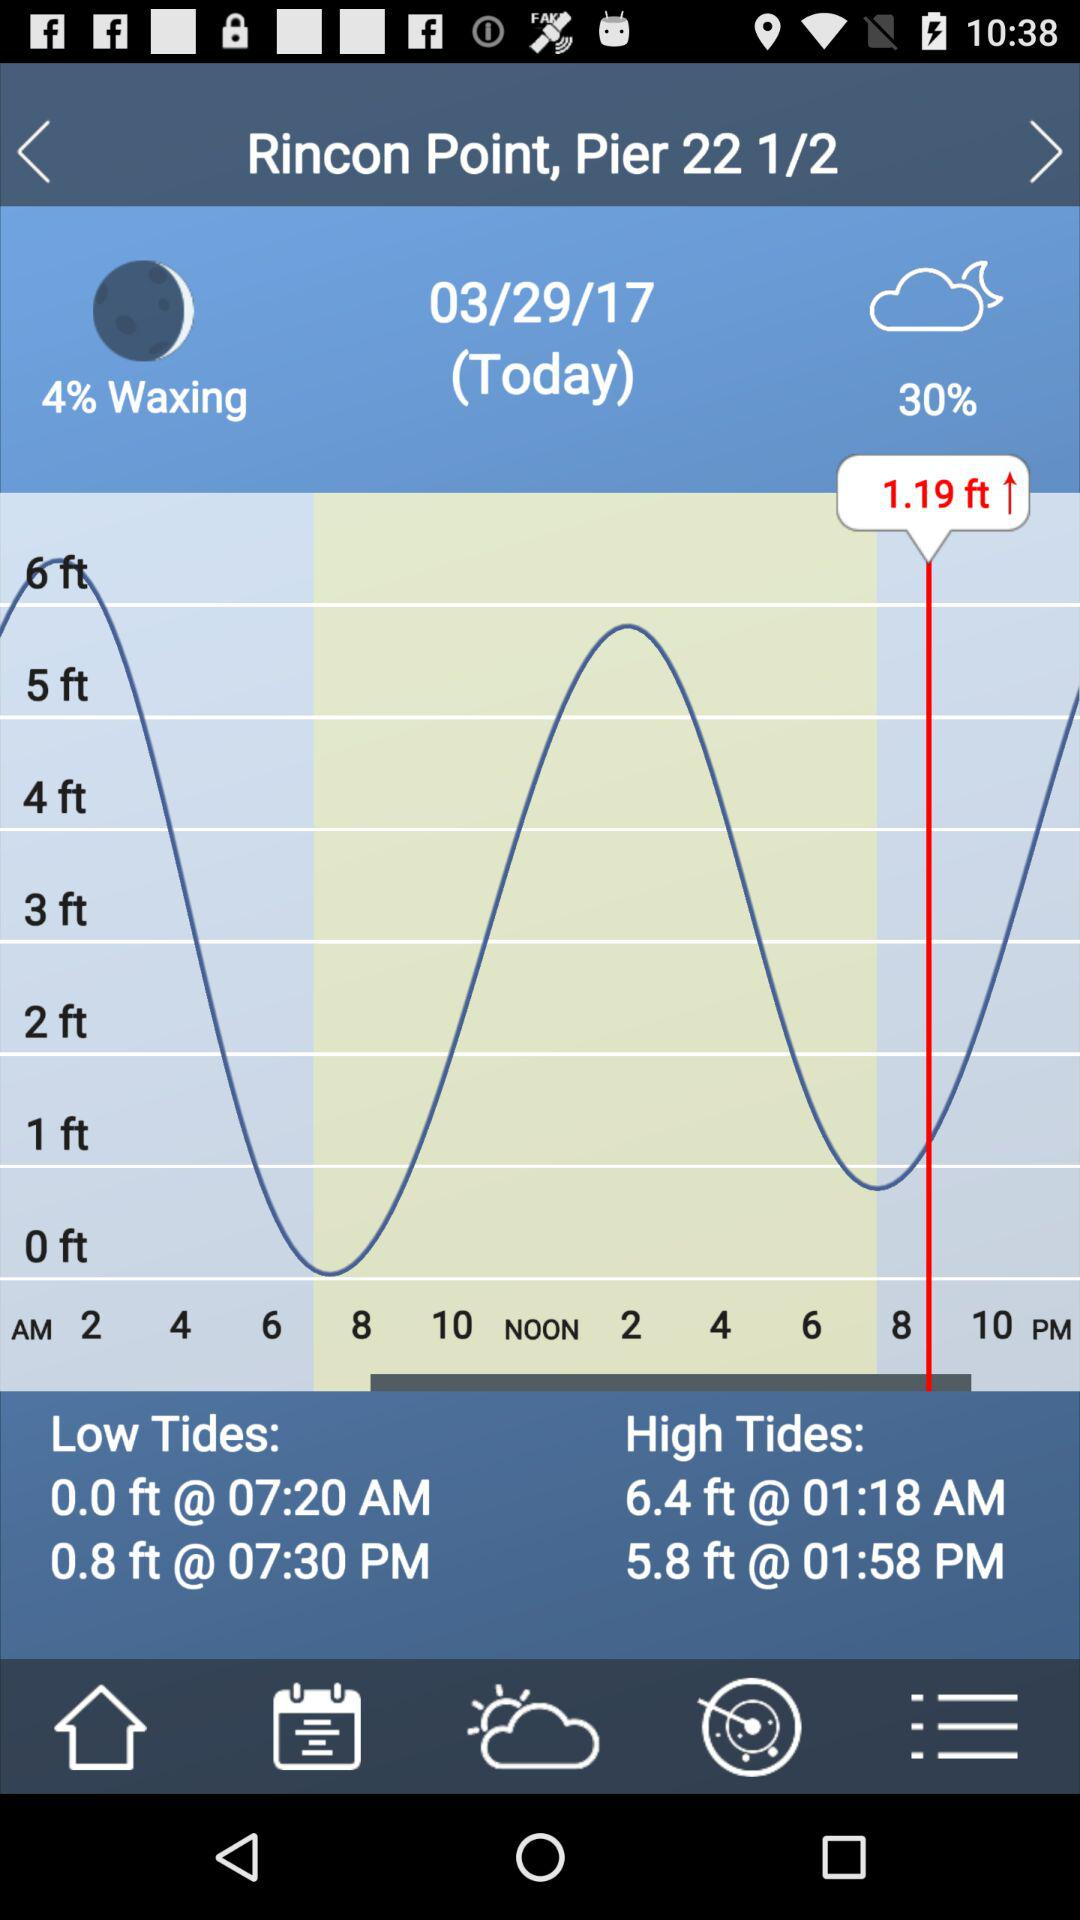What is the location given on the screen? The given location is Rincon Point, Pier 22 1/2. 